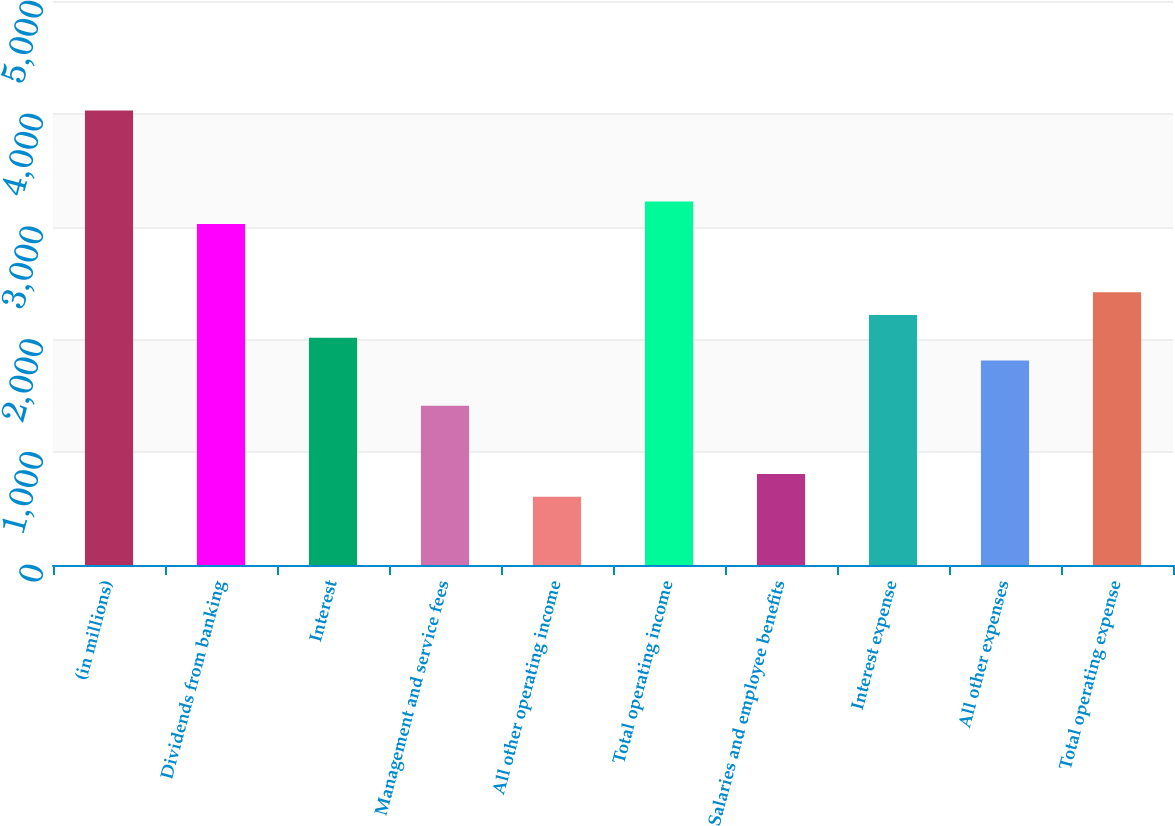<chart> <loc_0><loc_0><loc_500><loc_500><bar_chart><fcel>(in millions)<fcel>Dividends from banking<fcel>Interest<fcel>Management and service fees<fcel>All other operating income<fcel>Total operating income<fcel>Salaries and employee benefits<fcel>Interest expense<fcel>All other expenses<fcel>Total operating expense<nl><fcel>4029<fcel>3022<fcel>2015<fcel>1410.8<fcel>605.2<fcel>3223.4<fcel>806.6<fcel>2216.4<fcel>1813.6<fcel>2417.8<nl></chart> 